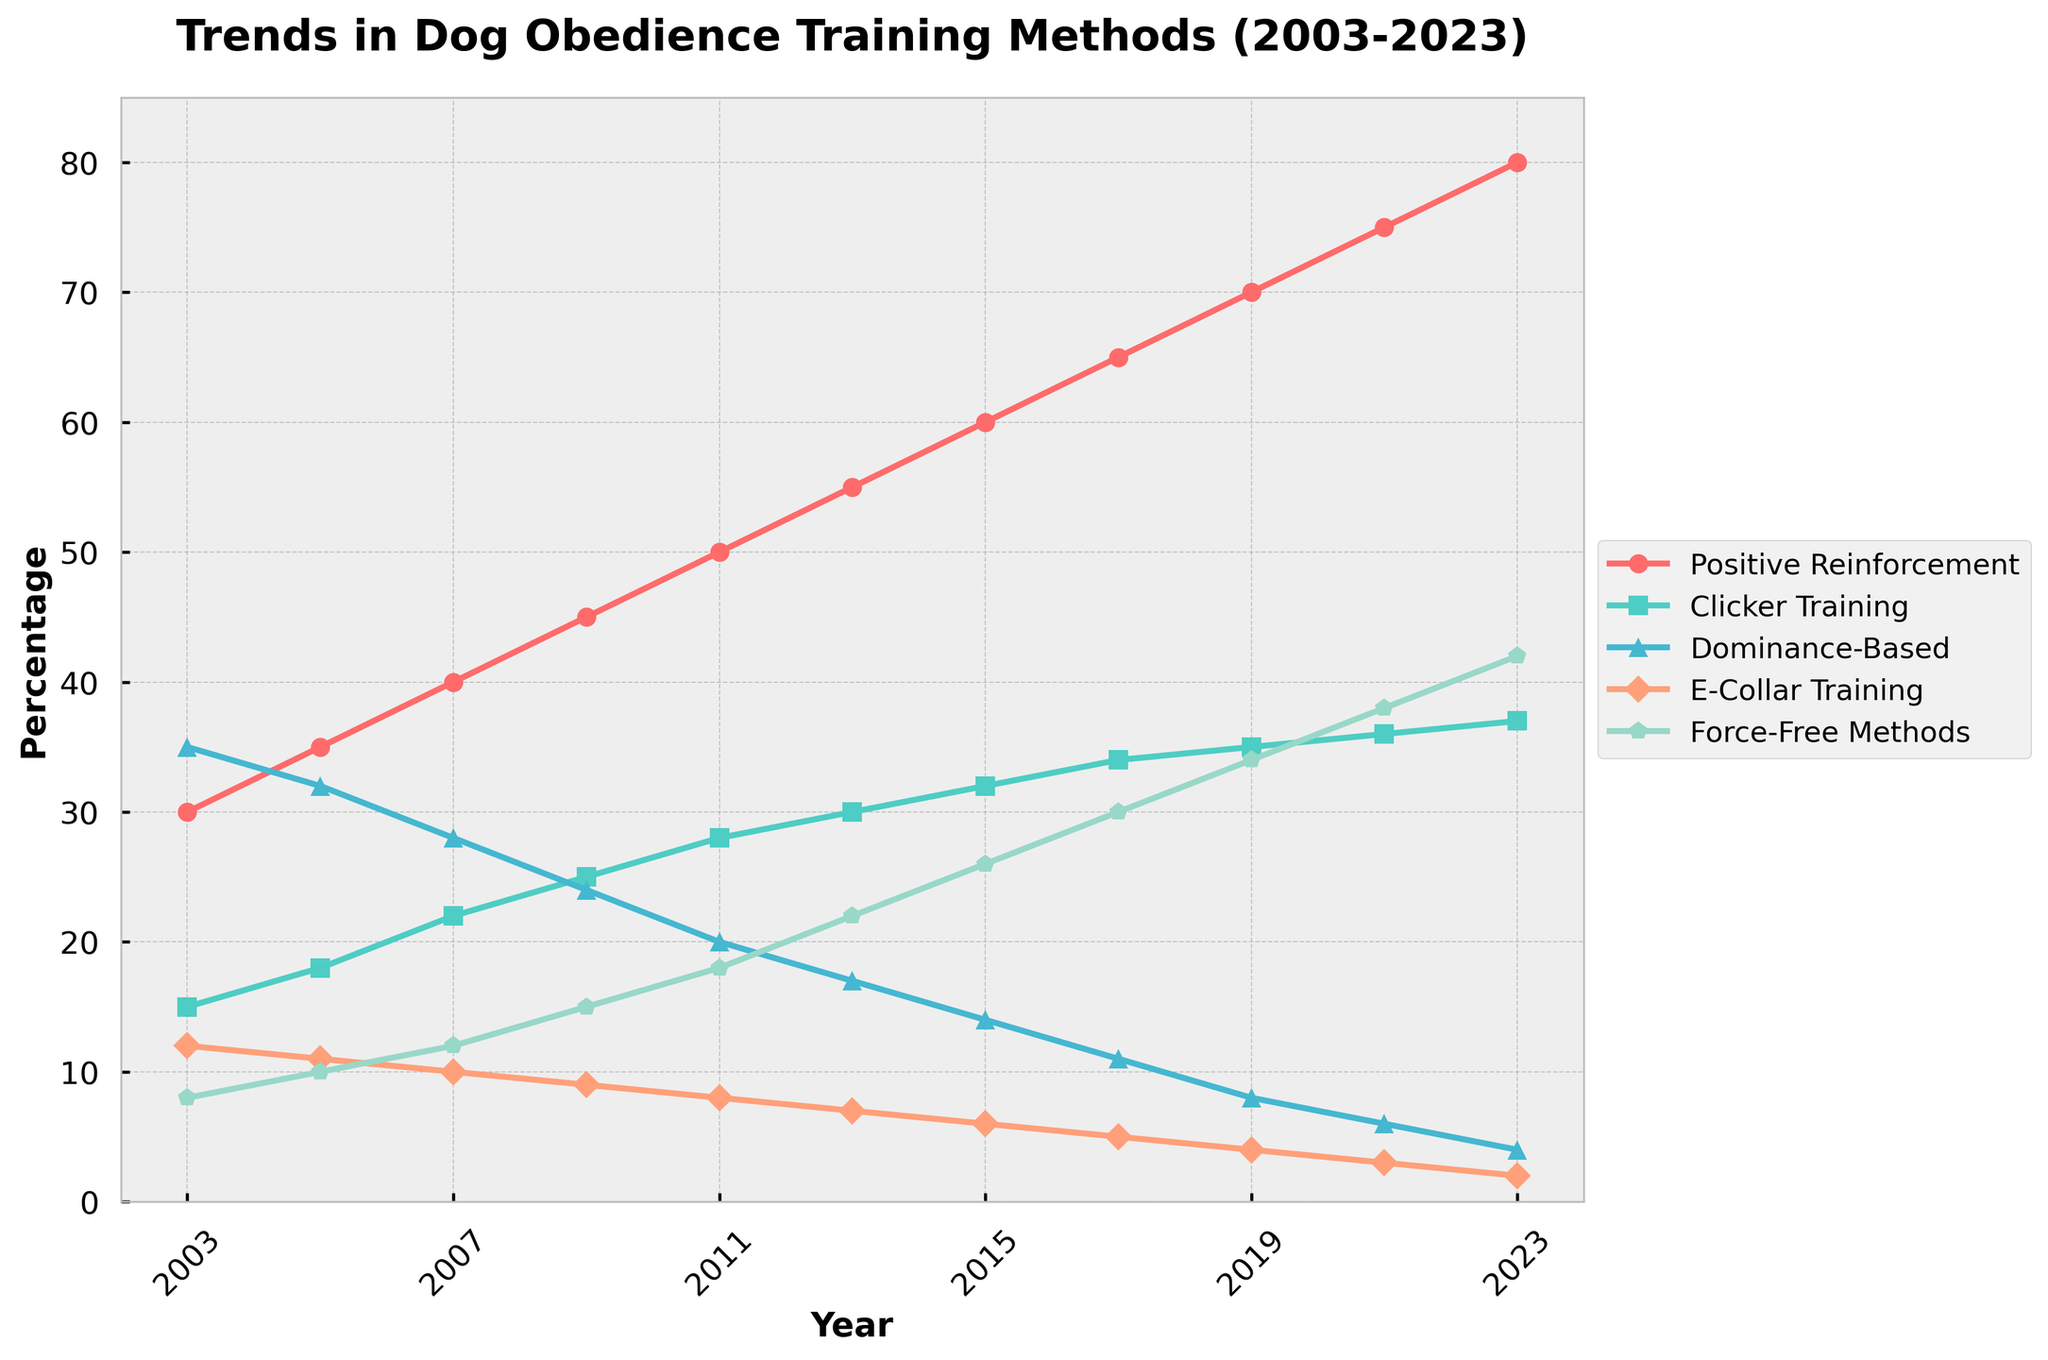What trend do you notice for Positive Reinforcement from 2003 to 2023? The trend line for Positive Reinforcement shows a consistent increase over the years from 30% in 2003 to 80% in 2023. This suggests that the popularity of Positive Reinforcement training methods has been steadily rising over the past 20 years.
Answer: Increasing trend Which training method had the highest percentage in 2003, and what was it? In 2003, the Dominance-Based training method had the highest percentage at 35%. This can be observed as it is the highest data point for that year across all training methods.
Answer: Dominance-Based (35%) Between which years did Clicker Training see the largest increase in percentage? Clicker Training saw the largest increase between 2003 and 2005, where it rose from 15% to 18%, which is a 3% increase. The other increments in percentage were smaller over the different time intervals.
Answer: 2003 to 2005 What is the percentage difference between Force-Free Methods and E-Collar Training in 2023? In 2023, Force-Free Methods had a percentage of 42%, while E-Collar Training had 2%. The difference between these percentages is calculated as 42% - 2% = 40%.
Answer: 40% Which training method shows a clear downward trend from 2003 to 2023? E-Collar Training shows a clear downward trend from 12% in 2003 to 2% in 2023. This is seen as its values continuously decrease over the years without any increase in between.
Answer: E-Collar Training By how many percent did Positive Reinforcement increase from 2015 to 2023? In 2015, Positive Reinforcement was at 60%, and in 2023 it was at 80%. The increase is calculated as 80% - 60% = 20%.
Answer: 20% How many training methods had a percentage above 30% in 2023? In 2023, both Positive Reinforcement (80%) and Force-Free Methods (42%) had percentages above 30%. This can be counted directly from the data.
Answer: 2 What is the average percentage of Clicker Training from 2003 to 2023? Adding all the Clicker Training percentages from 2003 to 2023 gives: 15 + 18 + 22 + 25 + 28 + 30 + 32 + 34 + 35 + 36 + 37 = 312. Dividing this by the number of years (11) results in an average of 312/11 = 28.36%.
Answer: 28.36% What was the trend in Dominance-Based training over the past 20 years? Dominance-Based training saw a clear decline, dropping from 35% in 2003 to 4% in 2023. This is evident as each data point from 2003 onwards decreases.
Answer: Decreasing trend 